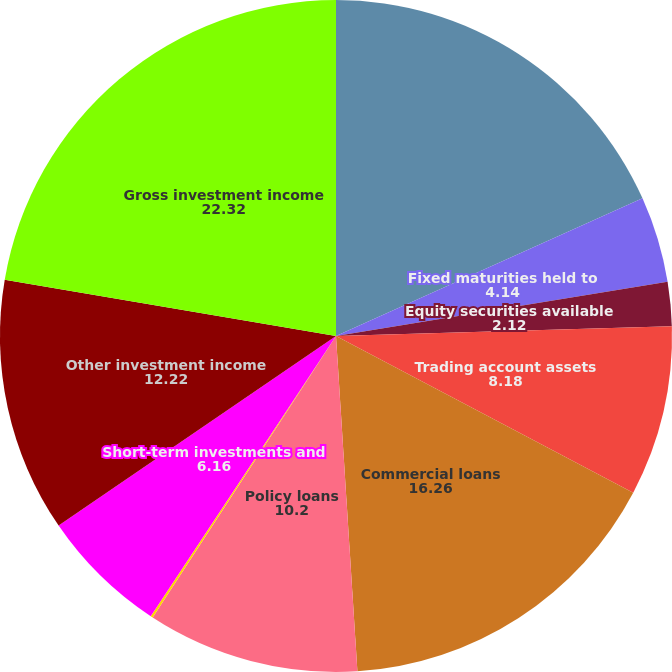Convert chart. <chart><loc_0><loc_0><loc_500><loc_500><pie_chart><fcel>Fixed maturities available for<fcel>Fixed maturities held to<fcel>Equity securities available<fcel>Trading account assets<fcel>Commercial loans<fcel>Policy loans<fcel>Broker-dealer related<fcel>Short-term investments and<fcel>Other investment income<fcel>Gross investment income<nl><fcel>18.28%<fcel>4.14%<fcel>2.12%<fcel>8.18%<fcel>16.26%<fcel>10.2%<fcel>0.11%<fcel>6.16%<fcel>12.22%<fcel>22.32%<nl></chart> 